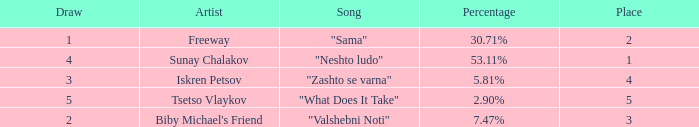What is the least draw when the place is higher than 4? 5.0. Could you parse the entire table as a dict? {'header': ['Draw', 'Artist', 'Song', 'Percentage', 'Place'], 'rows': [['1', 'Freeway', '"Sama"', '30.71%', '2'], ['4', 'Sunay Chalakov', '"Neshto ludo"', '53.11%', '1'], ['3', 'Iskren Petsov', '"Zashto se varna"', '5.81%', '4'], ['5', 'Tsetso Vlaykov', '"What Does It Take"', '2.90%', '5'], ['2', "Biby Michael's Friend", '"Valshebni Noti"', '7.47%', '3']]} 